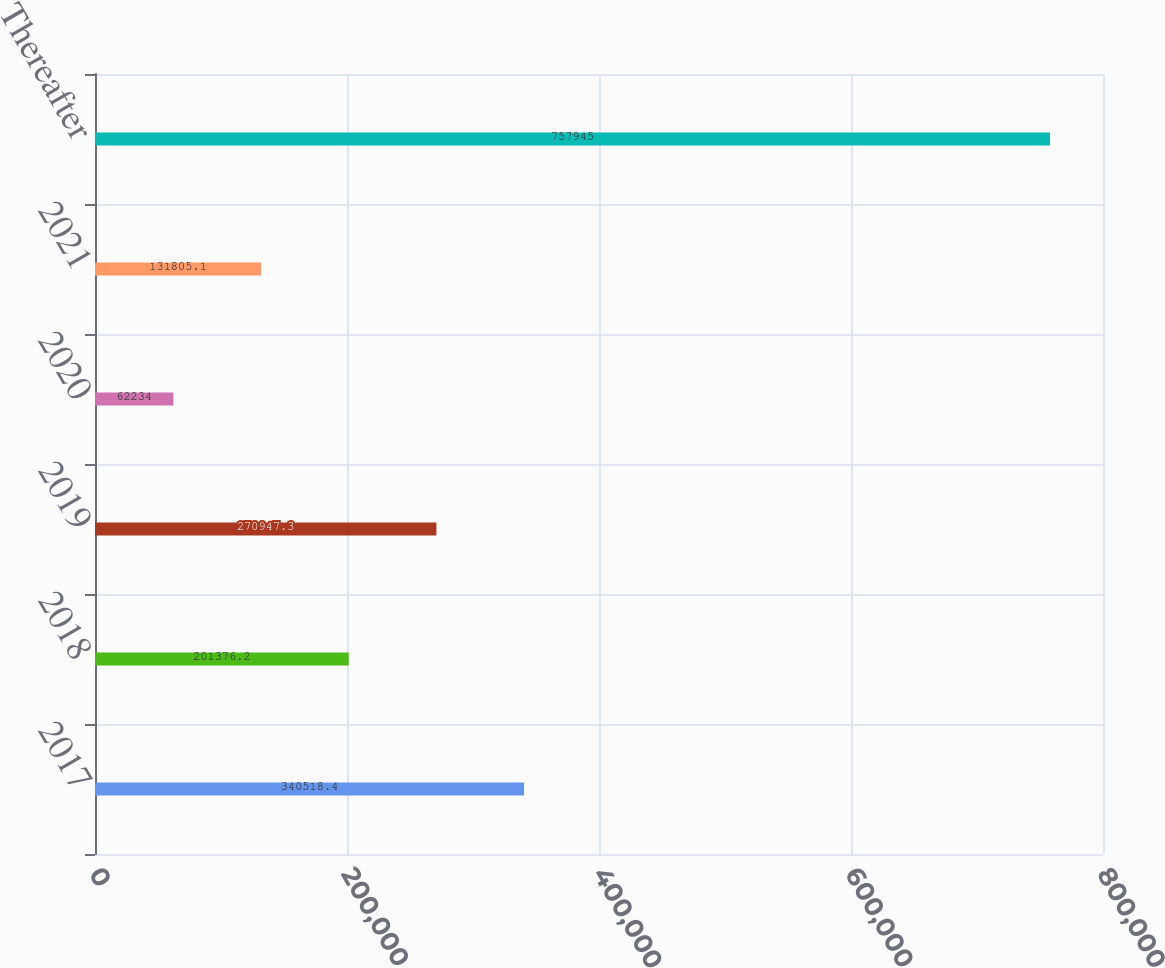Convert chart. <chart><loc_0><loc_0><loc_500><loc_500><bar_chart><fcel>2017<fcel>2018<fcel>2019<fcel>2020<fcel>2021<fcel>Thereafter<nl><fcel>340518<fcel>201376<fcel>270947<fcel>62234<fcel>131805<fcel>757945<nl></chart> 